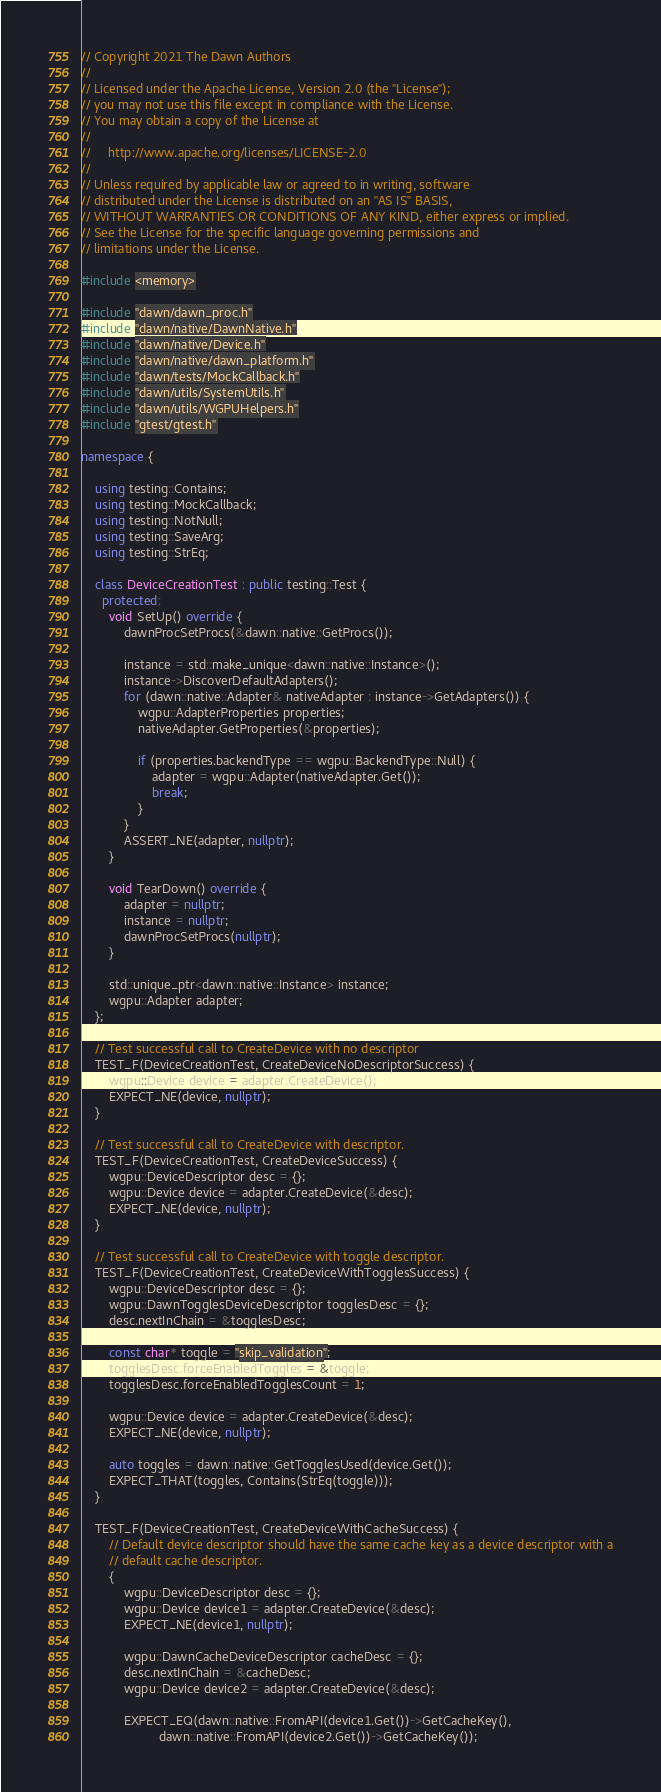<code> <loc_0><loc_0><loc_500><loc_500><_C++_>// Copyright 2021 The Dawn Authors
//
// Licensed under the Apache License, Version 2.0 (the "License");
// you may not use this file except in compliance with the License.
// You may obtain a copy of the License at
//
//     http://www.apache.org/licenses/LICENSE-2.0
//
// Unless required by applicable law or agreed to in writing, software
// distributed under the License is distributed on an "AS IS" BASIS,
// WITHOUT WARRANTIES OR CONDITIONS OF ANY KIND, either express or implied.
// See the License for the specific language governing permissions and
// limitations under the License.

#include <memory>

#include "dawn/dawn_proc.h"
#include "dawn/native/DawnNative.h"
#include "dawn/native/Device.h"
#include "dawn/native/dawn_platform.h"
#include "dawn/tests/MockCallback.h"
#include "dawn/utils/SystemUtils.h"
#include "dawn/utils/WGPUHelpers.h"
#include "gtest/gtest.h"

namespace {

    using testing::Contains;
    using testing::MockCallback;
    using testing::NotNull;
    using testing::SaveArg;
    using testing::StrEq;

    class DeviceCreationTest : public testing::Test {
      protected:
        void SetUp() override {
            dawnProcSetProcs(&dawn::native::GetProcs());

            instance = std::make_unique<dawn::native::Instance>();
            instance->DiscoverDefaultAdapters();
            for (dawn::native::Adapter& nativeAdapter : instance->GetAdapters()) {
                wgpu::AdapterProperties properties;
                nativeAdapter.GetProperties(&properties);

                if (properties.backendType == wgpu::BackendType::Null) {
                    adapter = wgpu::Adapter(nativeAdapter.Get());
                    break;
                }
            }
            ASSERT_NE(adapter, nullptr);
        }

        void TearDown() override {
            adapter = nullptr;
            instance = nullptr;
            dawnProcSetProcs(nullptr);
        }

        std::unique_ptr<dawn::native::Instance> instance;
        wgpu::Adapter adapter;
    };

    // Test successful call to CreateDevice with no descriptor
    TEST_F(DeviceCreationTest, CreateDeviceNoDescriptorSuccess) {
        wgpu::Device device = adapter.CreateDevice();
        EXPECT_NE(device, nullptr);
    }

    // Test successful call to CreateDevice with descriptor.
    TEST_F(DeviceCreationTest, CreateDeviceSuccess) {
        wgpu::DeviceDescriptor desc = {};
        wgpu::Device device = adapter.CreateDevice(&desc);
        EXPECT_NE(device, nullptr);
    }

    // Test successful call to CreateDevice with toggle descriptor.
    TEST_F(DeviceCreationTest, CreateDeviceWithTogglesSuccess) {
        wgpu::DeviceDescriptor desc = {};
        wgpu::DawnTogglesDeviceDescriptor togglesDesc = {};
        desc.nextInChain = &togglesDesc;

        const char* toggle = "skip_validation";
        togglesDesc.forceEnabledToggles = &toggle;
        togglesDesc.forceEnabledTogglesCount = 1;

        wgpu::Device device = adapter.CreateDevice(&desc);
        EXPECT_NE(device, nullptr);

        auto toggles = dawn::native::GetTogglesUsed(device.Get());
        EXPECT_THAT(toggles, Contains(StrEq(toggle)));
    }

    TEST_F(DeviceCreationTest, CreateDeviceWithCacheSuccess) {
        // Default device descriptor should have the same cache key as a device descriptor with a
        // default cache descriptor.
        {
            wgpu::DeviceDescriptor desc = {};
            wgpu::Device device1 = adapter.CreateDevice(&desc);
            EXPECT_NE(device1, nullptr);

            wgpu::DawnCacheDeviceDescriptor cacheDesc = {};
            desc.nextInChain = &cacheDesc;
            wgpu::Device device2 = adapter.CreateDevice(&desc);

            EXPECT_EQ(dawn::native::FromAPI(device1.Get())->GetCacheKey(),
                      dawn::native::FromAPI(device2.Get())->GetCacheKey());</code> 